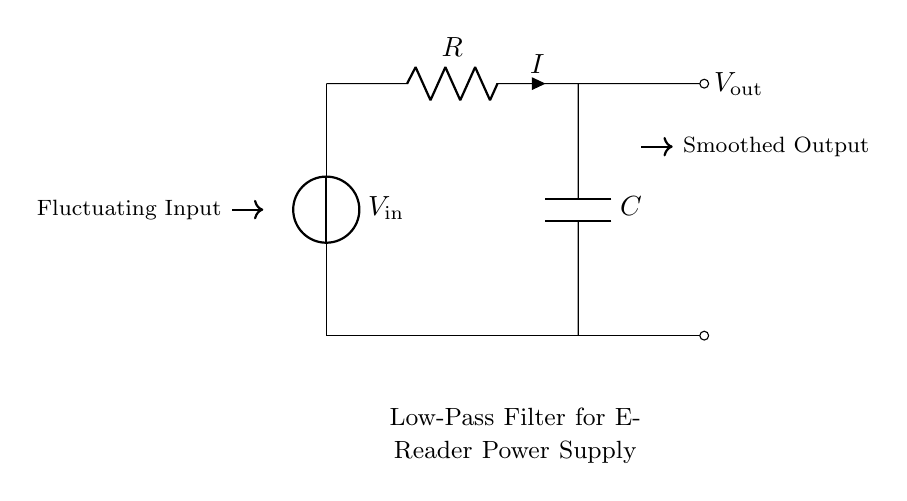What is the type of this circuit? This circuit is a low-pass filter, indicated by the arrangement of the resistor and capacitor that allows low-frequency signals to pass and attenuates high-frequency signals.
Answer: low-pass filter What components are in the circuit? The circuit contains a voltage source, a resistor, and a capacitor, which are the essential components for a low-pass filter design.
Answer: voltage source, resistor, capacitor What is the purpose of the resistor in this circuit? The resistor controls the current flow through the circuit and, in conjunction with the capacitor, determines the cutoff frequency of the filter, affecting how quickly it can respond to changes in the input signal.
Answer: current control What is the output voltage? The output voltage is taken across the capacitor, denoted as V_out in the circuit, which reflects the smoothed voltage after filtering the fluctuations.
Answer: V_out What happens to high-frequency signals in this circuit? High-frequency signals are attenuated or reduced in amplitude as they pass through the circuit, due to the combination of the resistor and capacitor which form the low-pass filter characteristics.
Answer: attenuated What is the relationship between the resistor and capacitor in determining the cutoff frequency? The cutoff frequency is determined by the values of the resistor and capacitor, and is calculated using the formula 1/(2πRC), where R is the resistance and C is the capacitance, indicating how they work together to define the filter's frequency response.
Answer: 1/(2πRC) What symbol denotes the input voltage? The symbol for the input voltage in the circuit is V_in, which is shown directly connected to the voltage source at the beginning of the circuit.
Answer: V_in 